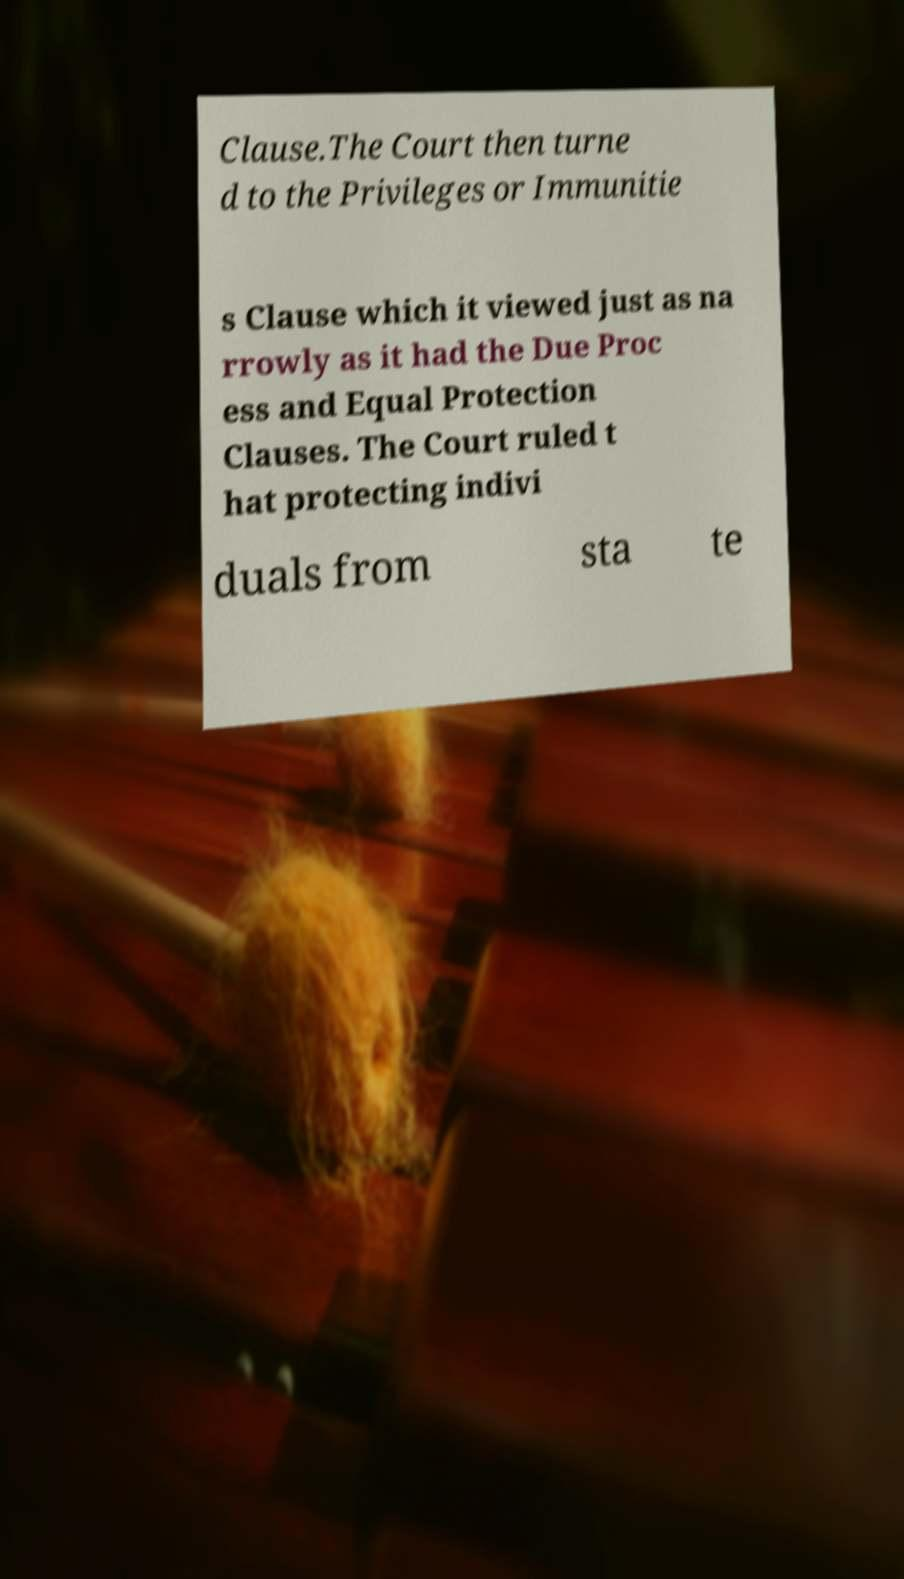For documentation purposes, I need the text within this image transcribed. Could you provide that? Clause.The Court then turne d to the Privileges or Immunitie s Clause which it viewed just as na rrowly as it had the Due Proc ess and Equal Protection Clauses. The Court ruled t hat protecting indivi duals from sta te 